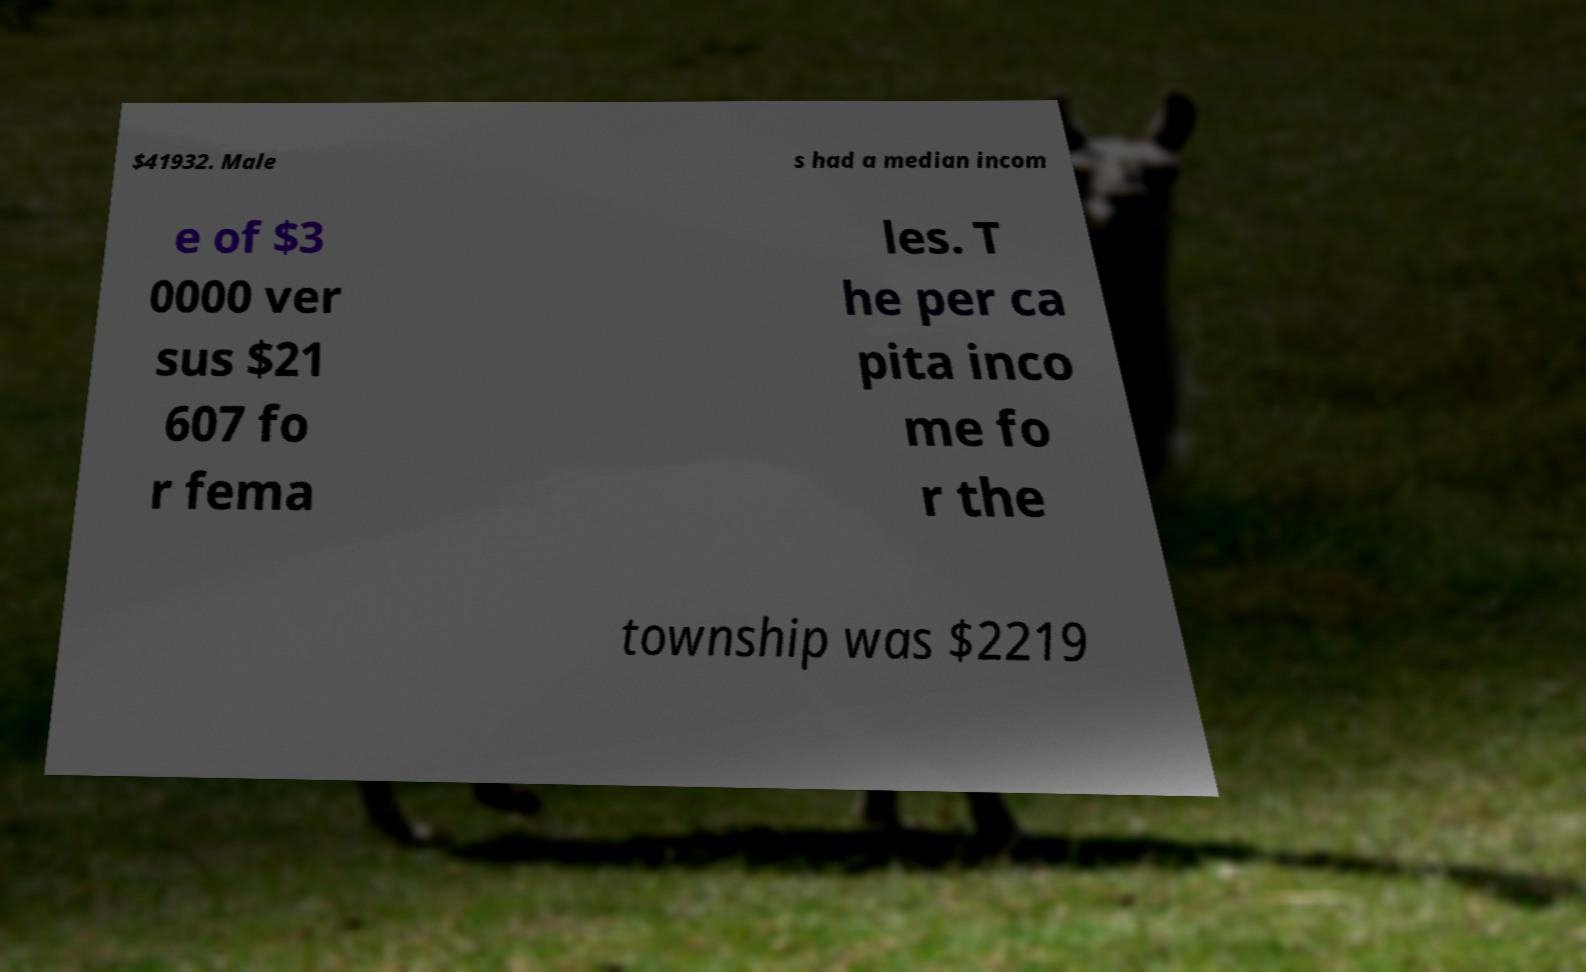Please identify and transcribe the text found in this image. $41932. Male s had a median incom e of $3 0000 ver sus $21 607 fo r fema les. T he per ca pita inco me fo r the township was $2219 